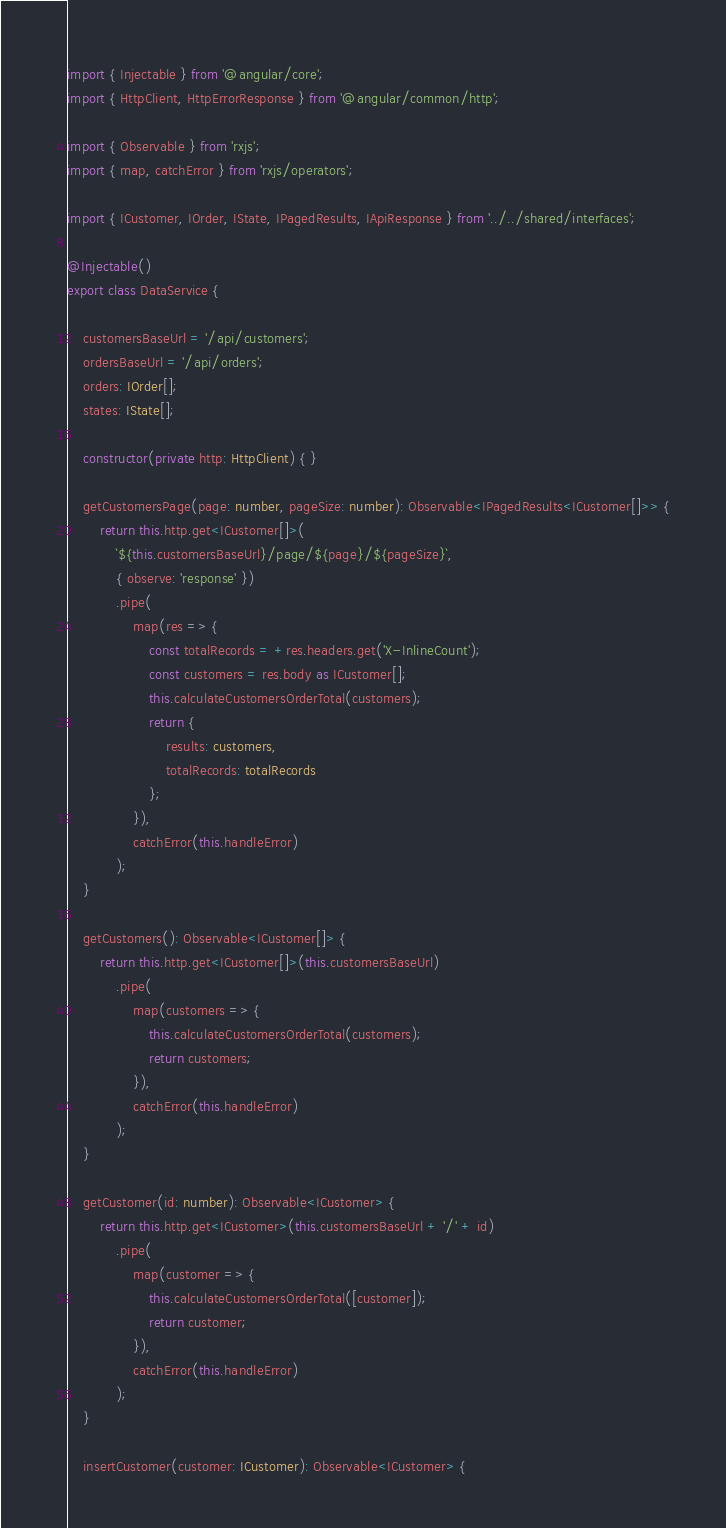Convert code to text. <code><loc_0><loc_0><loc_500><loc_500><_TypeScript_>import { Injectable } from '@angular/core';
import { HttpClient, HttpErrorResponse } from '@angular/common/http';

import { Observable } from 'rxjs';
import { map, catchError } from 'rxjs/operators';

import { ICustomer, IOrder, IState, IPagedResults, IApiResponse } from '../../shared/interfaces';

@Injectable()
export class DataService {

    customersBaseUrl = '/api/customers';
    ordersBaseUrl = '/api/orders';
    orders: IOrder[];
    states: IState[];

    constructor(private http: HttpClient) { }

    getCustomersPage(page: number, pageSize: number): Observable<IPagedResults<ICustomer[]>> {
        return this.http.get<ICustomer[]>(
            `${this.customersBaseUrl}/page/${page}/${pageSize}`,
            { observe: 'response' })
            .pipe(
                map(res => {
                    const totalRecords = +res.headers.get('X-InlineCount');
                    const customers = res.body as ICustomer[];
                    this.calculateCustomersOrderTotal(customers);
                    return {
                        results: customers,
                        totalRecords: totalRecords
                    };
                }),
                catchError(this.handleError)
            );
    }

    getCustomers(): Observable<ICustomer[]> {
        return this.http.get<ICustomer[]>(this.customersBaseUrl)
            .pipe(
                map(customers => {
                    this.calculateCustomersOrderTotal(customers);
                    return customers;
                }),
                catchError(this.handleError)
            );
    }

    getCustomer(id: number): Observable<ICustomer> {
        return this.http.get<ICustomer>(this.customersBaseUrl + '/' + id)
            .pipe(
                map(customer => {
                    this.calculateCustomersOrderTotal([customer]);
                    return customer;
                }),
                catchError(this.handleError)
            );
    }

    insertCustomer(customer: ICustomer): Observable<ICustomer> {</code> 